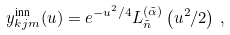<formula> <loc_0><loc_0><loc_500><loc_500>y ^ { \text {inn} } _ { k j m } ( u ) = e ^ { - u ^ { 2 } / 4 } L ^ { ( \tilde { \alpha } ) } _ { \tilde { n } } \left ( u ^ { 2 } / 2 \right ) \, ,</formula> 